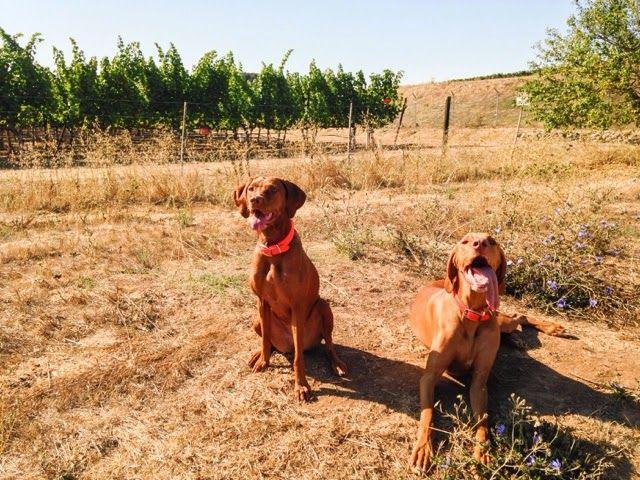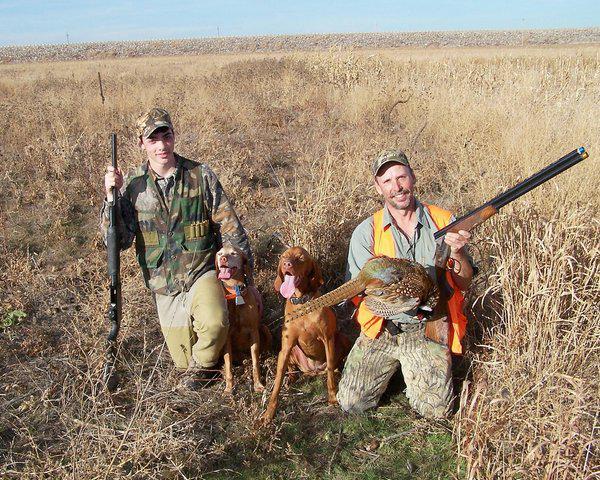The first image is the image on the left, the second image is the image on the right. Evaluate the accuracy of this statement regarding the images: "Nine or more mammals are present.". Is it true? Answer yes or no. No. The first image is the image on the left, the second image is the image on the right. Evaluate the accuracy of this statement regarding the images: "In one of the images hunters posing with their guns and prey.". Is it true? Answer yes or no. Yes. 